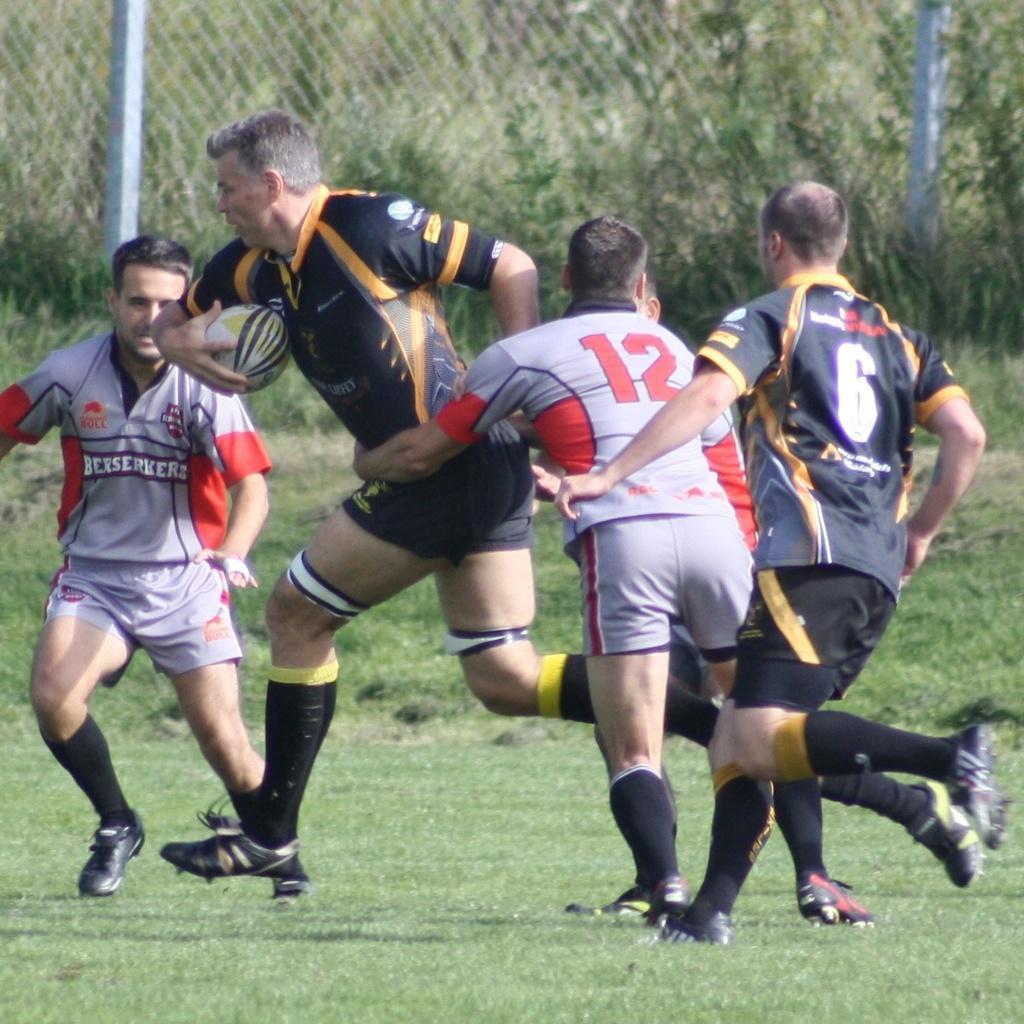How would you summarize this image in a sentence or two? In this image i can see group of people playing game at the back ground i can see a railing and a tree. 